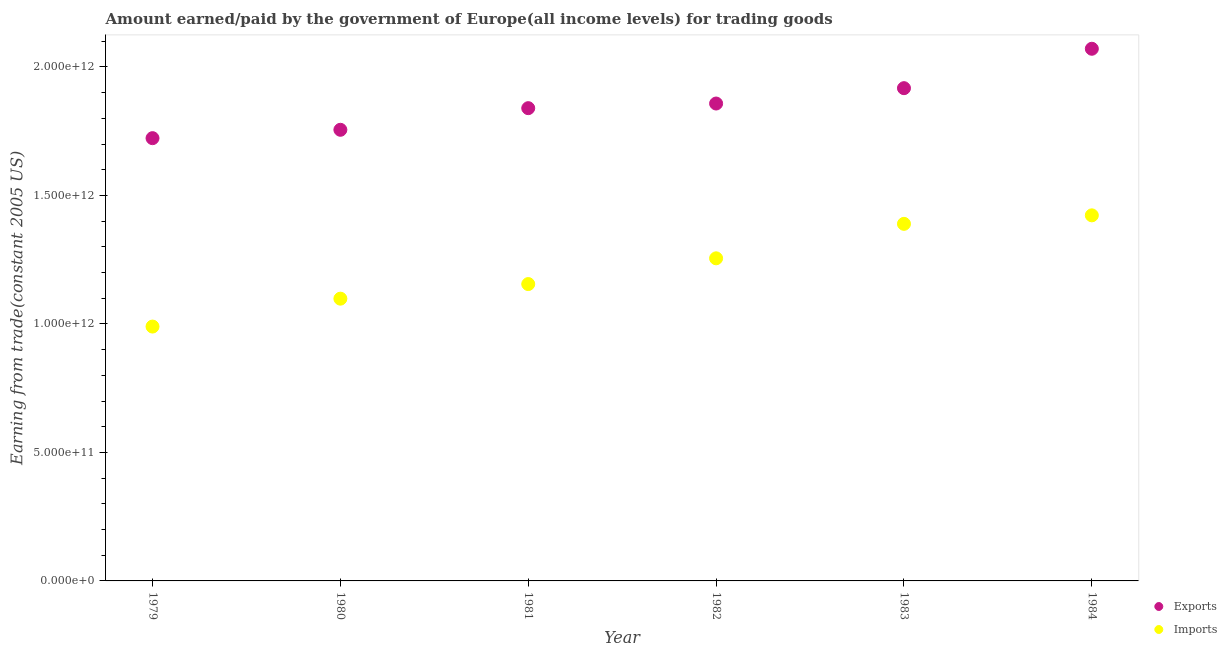How many different coloured dotlines are there?
Keep it short and to the point. 2. Is the number of dotlines equal to the number of legend labels?
Make the answer very short. Yes. What is the amount paid for imports in 1979?
Give a very brief answer. 9.90e+11. Across all years, what is the maximum amount paid for imports?
Ensure brevity in your answer.  1.42e+12. Across all years, what is the minimum amount paid for imports?
Give a very brief answer. 9.90e+11. In which year was the amount earned from exports maximum?
Your answer should be very brief. 1984. In which year was the amount paid for imports minimum?
Make the answer very short. 1979. What is the total amount earned from exports in the graph?
Offer a very short reply. 1.12e+13. What is the difference between the amount earned from exports in 1981 and that in 1984?
Your response must be concise. -2.31e+11. What is the difference between the amount earned from exports in 1981 and the amount paid for imports in 1983?
Ensure brevity in your answer.  4.50e+11. What is the average amount earned from exports per year?
Offer a very short reply. 1.86e+12. In the year 1980, what is the difference between the amount paid for imports and amount earned from exports?
Your answer should be very brief. -6.57e+11. In how many years, is the amount paid for imports greater than 1400000000000 US$?
Provide a succinct answer. 1. What is the ratio of the amount earned from exports in 1979 to that in 1980?
Provide a short and direct response. 0.98. What is the difference between the highest and the second highest amount earned from exports?
Your response must be concise. 1.53e+11. What is the difference between the highest and the lowest amount earned from exports?
Provide a short and direct response. 3.48e+11. In how many years, is the amount paid for imports greater than the average amount paid for imports taken over all years?
Your response must be concise. 3. Is the amount paid for imports strictly greater than the amount earned from exports over the years?
Keep it short and to the point. No. How many years are there in the graph?
Your answer should be compact. 6. What is the difference between two consecutive major ticks on the Y-axis?
Your answer should be compact. 5.00e+11. Are the values on the major ticks of Y-axis written in scientific E-notation?
Make the answer very short. Yes. Does the graph contain any zero values?
Ensure brevity in your answer.  No. Where does the legend appear in the graph?
Keep it short and to the point. Bottom right. What is the title of the graph?
Make the answer very short. Amount earned/paid by the government of Europe(all income levels) for trading goods. What is the label or title of the Y-axis?
Ensure brevity in your answer.  Earning from trade(constant 2005 US). What is the Earning from trade(constant 2005 US) in Exports in 1979?
Ensure brevity in your answer.  1.72e+12. What is the Earning from trade(constant 2005 US) of Imports in 1979?
Offer a terse response. 9.90e+11. What is the Earning from trade(constant 2005 US) in Exports in 1980?
Your response must be concise. 1.76e+12. What is the Earning from trade(constant 2005 US) of Imports in 1980?
Keep it short and to the point. 1.10e+12. What is the Earning from trade(constant 2005 US) in Exports in 1981?
Your response must be concise. 1.84e+12. What is the Earning from trade(constant 2005 US) in Imports in 1981?
Give a very brief answer. 1.16e+12. What is the Earning from trade(constant 2005 US) in Exports in 1982?
Provide a short and direct response. 1.86e+12. What is the Earning from trade(constant 2005 US) in Imports in 1982?
Keep it short and to the point. 1.26e+12. What is the Earning from trade(constant 2005 US) of Exports in 1983?
Offer a terse response. 1.92e+12. What is the Earning from trade(constant 2005 US) of Imports in 1983?
Give a very brief answer. 1.39e+12. What is the Earning from trade(constant 2005 US) of Exports in 1984?
Keep it short and to the point. 2.07e+12. What is the Earning from trade(constant 2005 US) in Imports in 1984?
Your answer should be compact. 1.42e+12. Across all years, what is the maximum Earning from trade(constant 2005 US) in Exports?
Your response must be concise. 2.07e+12. Across all years, what is the maximum Earning from trade(constant 2005 US) in Imports?
Provide a succinct answer. 1.42e+12. Across all years, what is the minimum Earning from trade(constant 2005 US) in Exports?
Ensure brevity in your answer.  1.72e+12. Across all years, what is the minimum Earning from trade(constant 2005 US) in Imports?
Your answer should be very brief. 9.90e+11. What is the total Earning from trade(constant 2005 US) of Exports in the graph?
Provide a succinct answer. 1.12e+13. What is the total Earning from trade(constant 2005 US) of Imports in the graph?
Ensure brevity in your answer.  7.31e+12. What is the difference between the Earning from trade(constant 2005 US) in Exports in 1979 and that in 1980?
Your answer should be very brief. -3.25e+1. What is the difference between the Earning from trade(constant 2005 US) in Imports in 1979 and that in 1980?
Offer a very short reply. -1.09e+11. What is the difference between the Earning from trade(constant 2005 US) in Exports in 1979 and that in 1981?
Your response must be concise. -1.17e+11. What is the difference between the Earning from trade(constant 2005 US) in Imports in 1979 and that in 1981?
Offer a very short reply. -1.65e+11. What is the difference between the Earning from trade(constant 2005 US) of Exports in 1979 and that in 1982?
Your answer should be compact. -1.35e+11. What is the difference between the Earning from trade(constant 2005 US) in Imports in 1979 and that in 1982?
Keep it short and to the point. -2.66e+11. What is the difference between the Earning from trade(constant 2005 US) of Exports in 1979 and that in 1983?
Offer a very short reply. -1.95e+11. What is the difference between the Earning from trade(constant 2005 US) in Imports in 1979 and that in 1983?
Keep it short and to the point. -4.00e+11. What is the difference between the Earning from trade(constant 2005 US) in Exports in 1979 and that in 1984?
Provide a succinct answer. -3.48e+11. What is the difference between the Earning from trade(constant 2005 US) of Imports in 1979 and that in 1984?
Make the answer very short. -4.33e+11. What is the difference between the Earning from trade(constant 2005 US) in Exports in 1980 and that in 1981?
Give a very brief answer. -8.42e+1. What is the difference between the Earning from trade(constant 2005 US) in Imports in 1980 and that in 1981?
Make the answer very short. -5.68e+1. What is the difference between the Earning from trade(constant 2005 US) in Exports in 1980 and that in 1982?
Ensure brevity in your answer.  -1.02e+11. What is the difference between the Earning from trade(constant 2005 US) in Imports in 1980 and that in 1982?
Your answer should be very brief. -1.57e+11. What is the difference between the Earning from trade(constant 2005 US) of Exports in 1980 and that in 1983?
Ensure brevity in your answer.  -1.62e+11. What is the difference between the Earning from trade(constant 2005 US) in Imports in 1980 and that in 1983?
Your answer should be very brief. -2.91e+11. What is the difference between the Earning from trade(constant 2005 US) of Exports in 1980 and that in 1984?
Make the answer very short. -3.15e+11. What is the difference between the Earning from trade(constant 2005 US) of Imports in 1980 and that in 1984?
Provide a succinct answer. -3.24e+11. What is the difference between the Earning from trade(constant 2005 US) in Exports in 1981 and that in 1982?
Make the answer very short. -1.81e+1. What is the difference between the Earning from trade(constant 2005 US) in Imports in 1981 and that in 1982?
Provide a succinct answer. -1.00e+11. What is the difference between the Earning from trade(constant 2005 US) in Exports in 1981 and that in 1983?
Ensure brevity in your answer.  -7.78e+1. What is the difference between the Earning from trade(constant 2005 US) of Imports in 1981 and that in 1983?
Offer a very short reply. -2.34e+11. What is the difference between the Earning from trade(constant 2005 US) in Exports in 1981 and that in 1984?
Provide a succinct answer. -2.31e+11. What is the difference between the Earning from trade(constant 2005 US) in Imports in 1981 and that in 1984?
Your answer should be compact. -2.67e+11. What is the difference between the Earning from trade(constant 2005 US) in Exports in 1982 and that in 1983?
Give a very brief answer. -5.98e+1. What is the difference between the Earning from trade(constant 2005 US) of Imports in 1982 and that in 1983?
Keep it short and to the point. -1.34e+11. What is the difference between the Earning from trade(constant 2005 US) of Exports in 1982 and that in 1984?
Your answer should be compact. -2.13e+11. What is the difference between the Earning from trade(constant 2005 US) of Imports in 1982 and that in 1984?
Give a very brief answer. -1.67e+11. What is the difference between the Earning from trade(constant 2005 US) of Exports in 1983 and that in 1984?
Your answer should be very brief. -1.53e+11. What is the difference between the Earning from trade(constant 2005 US) of Imports in 1983 and that in 1984?
Keep it short and to the point. -3.31e+1. What is the difference between the Earning from trade(constant 2005 US) of Exports in 1979 and the Earning from trade(constant 2005 US) of Imports in 1980?
Your response must be concise. 6.25e+11. What is the difference between the Earning from trade(constant 2005 US) in Exports in 1979 and the Earning from trade(constant 2005 US) in Imports in 1981?
Provide a short and direct response. 5.68e+11. What is the difference between the Earning from trade(constant 2005 US) in Exports in 1979 and the Earning from trade(constant 2005 US) in Imports in 1982?
Give a very brief answer. 4.68e+11. What is the difference between the Earning from trade(constant 2005 US) in Exports in 1979 and the Earning from trade(constant 2005 US) in Imports in 1983?
Provide a short and direct response. 3.33e+11. What is the difference between the Earning from trade(constant 2005 US) in Exports in 1979 and the Earning from trade(constant 2005 US) in Imports in 1984?
Make the answer very short. 3.00e+11. What is the difference between the Earning from trade(constant 2005 US) in Exports in 1980 and the Earning from trade(constant 2005 US) in Imports in 1981?
Provide a short and direct response. 6.00e+11. What is the difference between the Earning from trade(constant 2005 US) of Exports in 1980 and the Earning from trade(constant 2005 US) of Imports in 1982?
Provide a short and direct response. 5.00e+11. What is the difference between the Earning from trade(constant 2005 US) in Exports in 1980 and the Earning from trade(constant 2005 US) in Imports in 1983?
Your answer should be compact. 3.66e+11. What is the difference between the Earning from trade(constant 2005 US) in Exports in 1980 and the Earning from trade(constant 2005 US) in Imports in 1984?
Your answer should be very brief. 3.33e+11. What is the difference between the Earning from trade(constant 2005 US) of Exports in 1981 and the Earning from trade(constant 2005 US) of Imports in 1982?
Offer a very short reply. 5.84e+11. What is the difference between the Earning from trade(constant 2005 US) in Exports in 1981 and the Earning from trade(constant 2005 US) in Imports in 1983?
Your answer should be compact. 4.50e+11. What is the difference between the Earning from trade(constant 2005 US) in Exports in 1981 and the Earning from trade(constant 2005 US) in Imports in 1984?
Make the answer very short. 4.17e+11. What is the difference between the Earning from trade(constant 2005 US) of Exports in 1982 and the Earning from trade(constant 2005 US) of Imports in 1983?
Make the answer very short. 4.68e+11. What is the difference between the Earning from trade(constant 2005 US) of Exports in 1982 and the Earning from trade(constant 2005 US) of Imports in 1984?
Provide a succinct answer. 4.35e+11. What is the difference between the Earning from trade(constant 2005 US) in Exports in 1983 and the Earning from trade(constant 2005 US) in Imports in 1984?
Keep it short and to the point. 4.95e+11. What is the average Earning from trade(constant 2005 US) of Exports per year?
Provide a short and direct response. 1.86e+12. What is the average Earning from trade(constant 2005 US) in Imports per year?
Give a very brief answer. 1.22e+12. In the year 1979, what is the difference between the Earning from trade(constant 2005 US) of Exports and Earning from trade(constant 2005 US) of Imports?
Give a very brief answer. 7.33e+11. In the year 1980, what is the difference between the Earning from trade(constant 2005 US) of Exports and Earning from trade(constant 2005 US) of Imports?
Provide a succinct answer. 6.57e+11. In the year 1981, what is the difference between the Earning from trade(constant 2005 US) in Exports and Earning from trade(constant 2005 US) in Imports?
Keep it short and to the point. 6.84e+11. In the year 1982, what is the difference between the Earning from trade(constant 2005 US) of Exports and Earning from trade(constant 2005 US) of Imports?
Your answer should be very brief. 6.02e+11. In the year 1983, what is the difference between the Earning from trade(constant 2005 US) in Exports and Earning from trade(constant 2005 US) in Imports?
Keep it short and to the point. 5.28e+11. In the year 1984, what is the difference between the Earning from trade(constant 2005 US) in Exports and Earning from trade(constant 2005 US) in Imports?
Offer a terse response. 6.48e+11. What is the ratio of the Earning from trade(constant 2005 US) in Exports in 1979 to that in 1980?
Provide a short and direct response. 0.98. What is the ratio of the Earning from trade(constant 2005 US) in Imports in 1979 to that in 1980?
Your answer should be very brief. 0.9. What is the ratio of the Earning from trade(constant 2005 US) in Exports in 1979 to that in 1981?
Make the answer very short. 0.94. What is the ratio of the Earning from trade(constant 2005 US) of Imports in 1979 to that in 1981?
Provide a short and direct response. 0.86. What is the ratio of the Earning from trade(constant 2005 US) of Exports in 1979 to that in 1982?
Your response must be concise. 0.93. What is the ratio of the Earning from trade(constant 2005 US) of Imports in 1979 to that in 1982?
Ensure brevity in your answer.  0.79. What is the ratio of the Earning from trade(constant 2005 US) of Exports in 1979 to that in 1983?
Your response must be concise. 0.9. What is the ratio of the Earning from trade(constant 2005 US) of Imports in 1979 to that in 1983?
Give a very brief answer. 0.71. What is the ratio of the Earning from trade(constant 2005 US) of Exports in 1979 to that in 1984?
Ensure brevity in your answer.  0.83. What is the ratio of the Earning from trade(constant 2005 US) of Imports in 1979 to that in 1984?
Make the answer very short. 0.7. What is the ratio of the Earning from trade(constant 2005 US) in Exports in 1980 to that in 1981?
Your answer should be very brief. 0.95. What is the ratio of the Earning from trade(constant 2005 US) of Imports in 1980 to that in 1981?
Your answer should be very brief. 0.95. What is the ratio of the Earning from trade(constant 2005 US) in Exports in 1980 to that in 1982?
Your answer should be compact. 0.94. What is the ratio of the Earning from trade(constant 2005 US) of Imports in 1980 to that in 1982?
Provide a succinct answer. 0.87. What is the ratio of the Earning from trade(constant 2005 US) of Exports in 1980 to that in 1983?
Keep it short and to the point. 0.92. What is the ratio of the Earning from trade(constant 2005 US) of Imports in 1980 to that in 1983?
Your response must be concise. 0.79. What is the ratio of the Earning from trade(constant 2005 US) of Exports in 1980 to that in 1984?
Keep it short and to the point. 0.85. What is the ratio of the Earning from trade(constant 2005 US) in Imports in 1980 to that in 1984?
Ensure brevity in your answer.  0.77. What is the ratio of the Earning from trade(constant 2005 US) in Exports in 1981 to that in 1982?
Give a very brief answer. 0.99. What is the ratio of the Earning from trade(constant 2005 US) in Imports in 1981 to that in 1982?
Offer a terse response. 0.92. What is the ratio of the Earning from trade(constant 2005 US) in Exports in 1981 to that in 1983?
Your answer should be compact. 0.96. What is the ratio of the Earning from trade(constant 2005 US) in Imports in 1981 to that in 1983?
Your answer should be very brief. 0.83. What is the ratio of the Earning from trade(constant 2005 US) in Exports in 1981 to that in 1984?
Ensure brevity in your answer.  0.89. What is the ratio of the Earning from trade(constant 2005 US) of Imports in 1981 to that in 1984?
Your answer should be compact. 0.81. What is the ratio of the Earning from trade(constant 2005 US) in Exports in 1982 to that in 1983?
Ensure brevity in your answer.  0.97. What is the ratio of the Earning from trade(constant 2005 US) in Imports in 1982 to that in 1983?
Your answer should be very brief. 0.9. What is the ratio of the Earning from trade(constant 2005 US) of Exports in 1982 to that in 1984?
Ensure brevity in your answer.  0.9. What is the ratio of the Earning from trade(constant 2005 US) in Imports in 1982 to that in 1984?
Ensure brevity in your answer.  0.88. What is the ratio of the Earning from trade(constant 2005 US) of Exports in 1983 to that in 1984?
Provide a succinct answer. 0.93. What is the ratio of the Earning from trade(constant 2005 US) in Imports in 1983 to that in 1984?
Provide a succinct answer. 0.98. What is the difference between the highest and the second highest Earning from trade(constant 2005 US) of Exports?
Make the answer very short. 1.53e+11. What is the difference between the highest and the second highest Earning from trade(constant 2005 US) of Imports?
Make the answer very short. 3.31e+1. What is the difference between the highest and the lowest Earning from trade(constant 2005 US) in Exports?
Offer a very short reply. 3.48e+11. What is the difference between the highest and the lowest Earning from trade(constant 2005 US) of Imports?
Ensure brevity in your answer.  4.33e+11. 